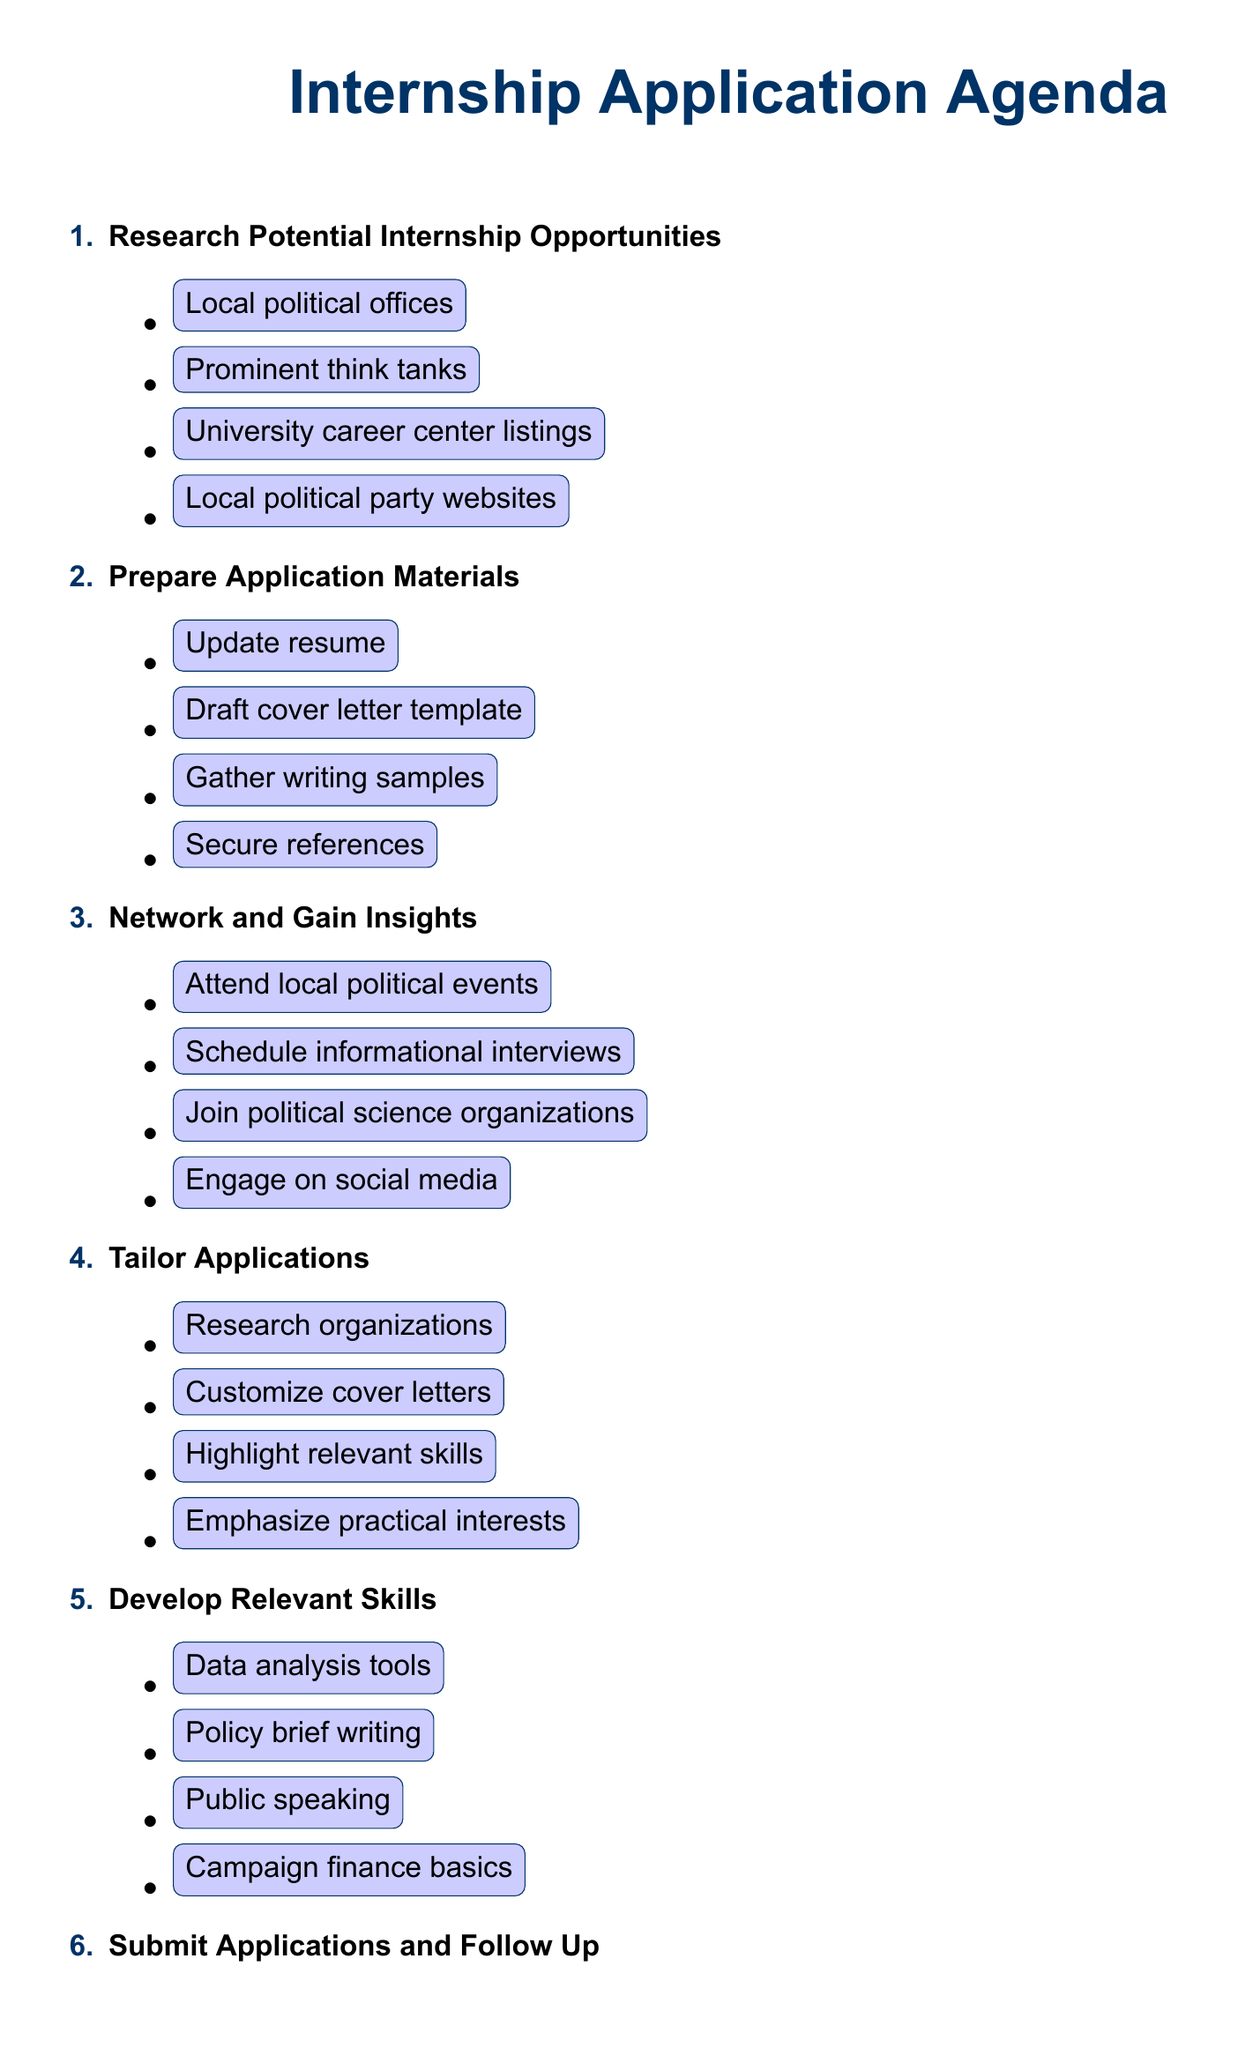What is the first agenda item? The agenda's first item is about researching potential internship opportunities.
Answer: Research Potential Internship Opportunities How many prominent think tanks are listed in the tasks? There are three prominent think tanks mentioned in the tasks under the first agenda item.
Answer: Three What is the purpose of updating the resume? The purpose is to highlight political science coursework and relevant skills.
Answer: Highlight political science coursework and relevant skills Which skill is emphasized for improvement in the fifth agenda item? The skill emphasized for improvement is data analysis.
Answer: Data analysis What should you do one week after submitting an application? One week after submission, you should send follow-up emails.
Answer: Send follow-up emails What type of events should you attend for networking? You should attend local political events and town halls.
Answer: Local political events and town halls What should be the focus of tailored applications? The focus should be on aligning with specific internship descriptions.
Answer: Align with specific internship descriptions How many tasks are listed under the "Develop Relevant Skills" agenda item? There are four tasks listed to develop relevant skills.
Answer: Four What should you review to prepare for success? You should review current events and local political issues.
Answer: Current events and local political issues 